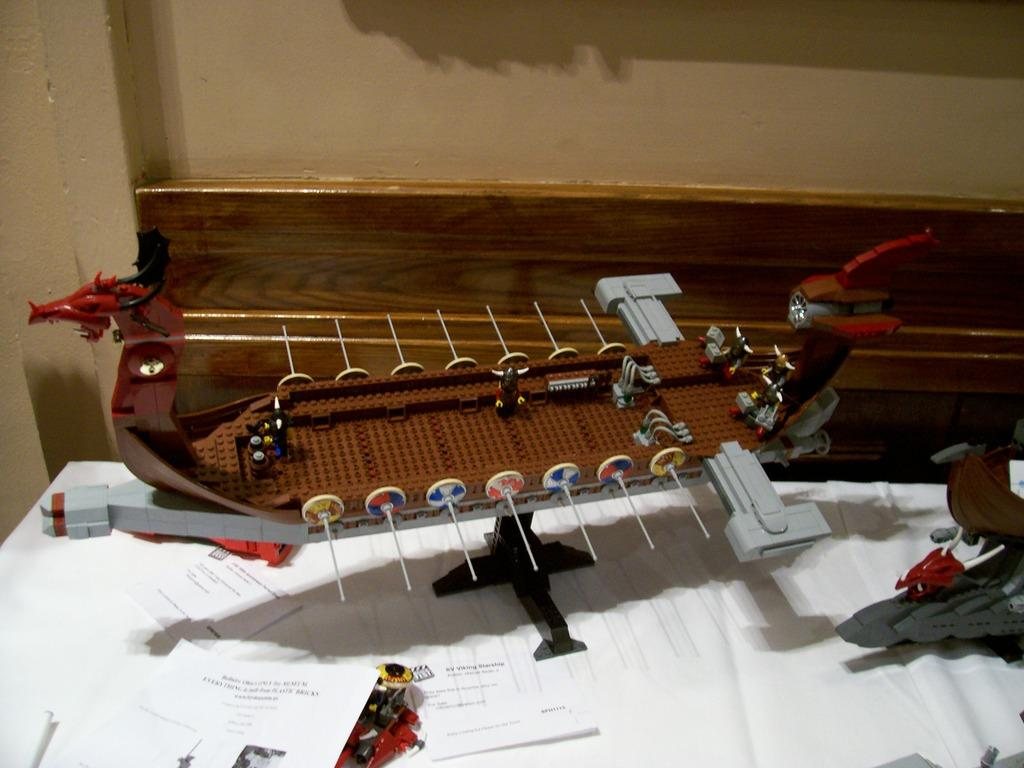What is on the table in the image? There are papers and objects on the table in the image. What can be seen on the wall behind the table? There is a wooden fence on the wall behind the table. What type of fan is used to measure the temperature in the image? There is no fan or temperature measurement device present in the image. What musical instrument can be seen on the table in the image? There are no musical instruments visible on the table in the image. 